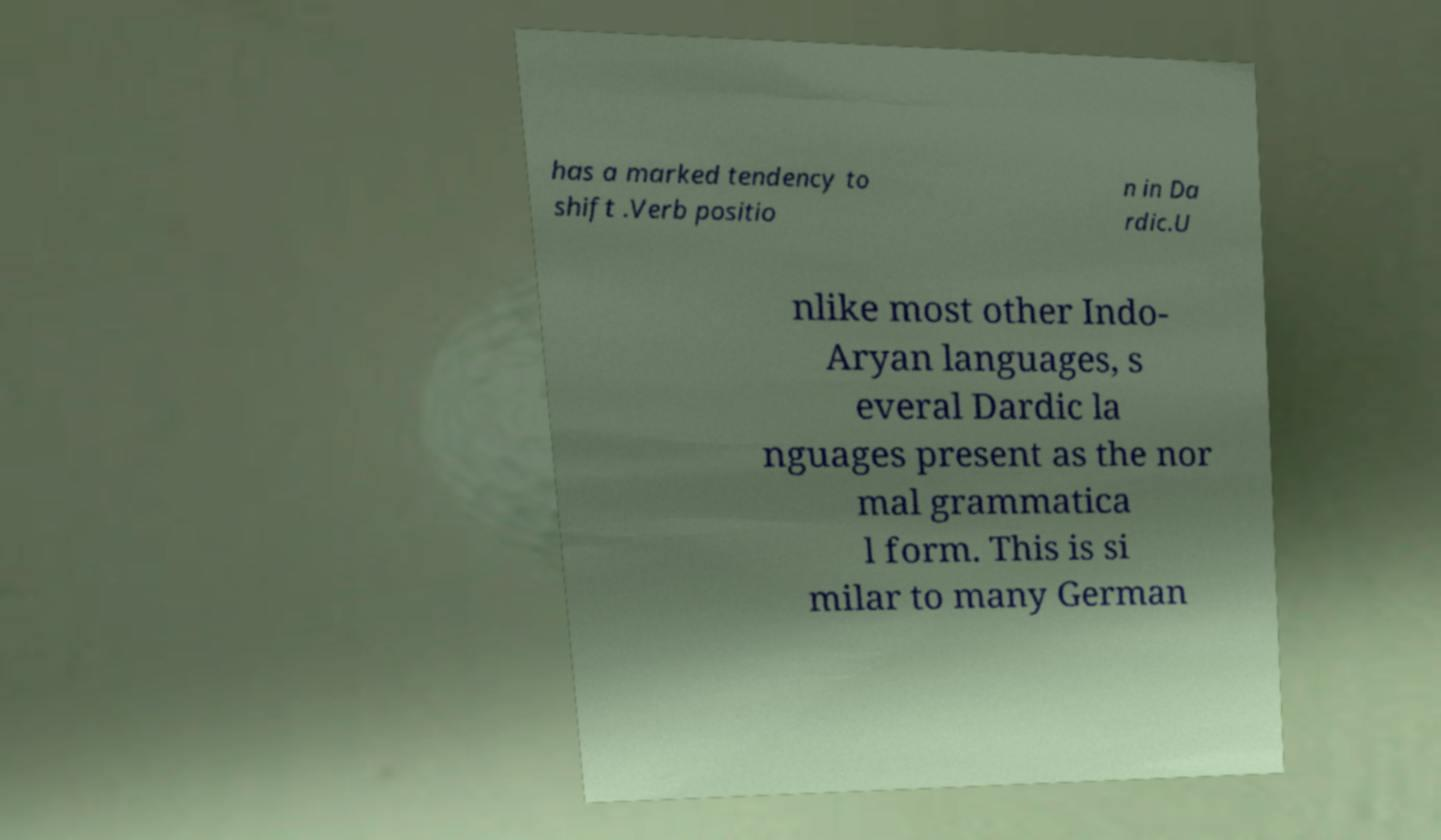Could you extract and type out the text from this image? has a marked tendency to shift .Verb positio n in Da rdic.U nlike most other Indo- Aryan languages, s everal Dardic la nguages present as the nor mal grammatica l form. This is si milar to many German 